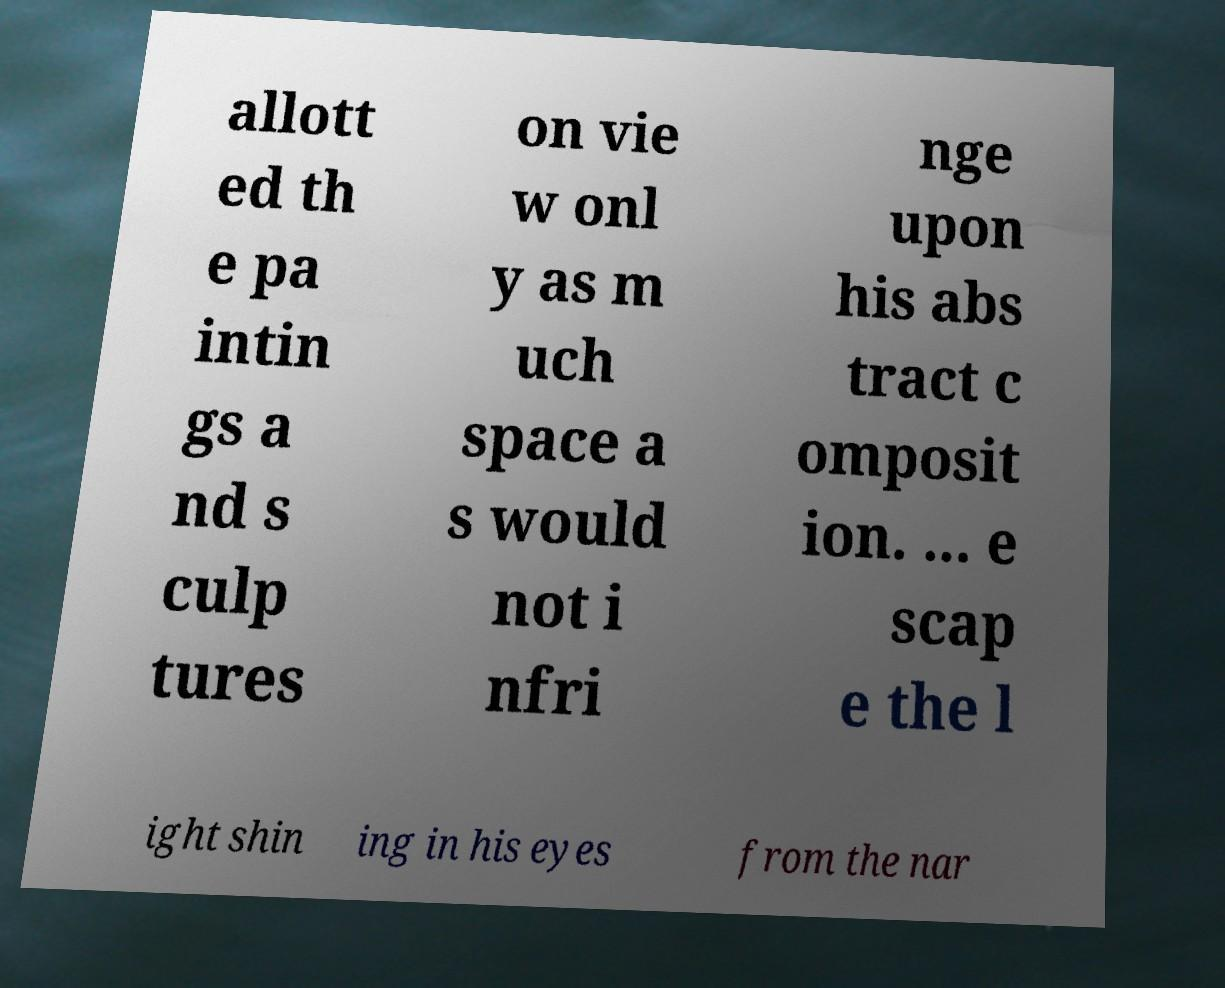I need the written content from this picture converted into text. Can you do that? allott ed th e pa intin gs a nd s culp tures on vie w onl y as m uch space a s would not i nfri nge upon his abs tract c omposit ion. ... e scap e the l ight shin ing in his eyes from the nar 